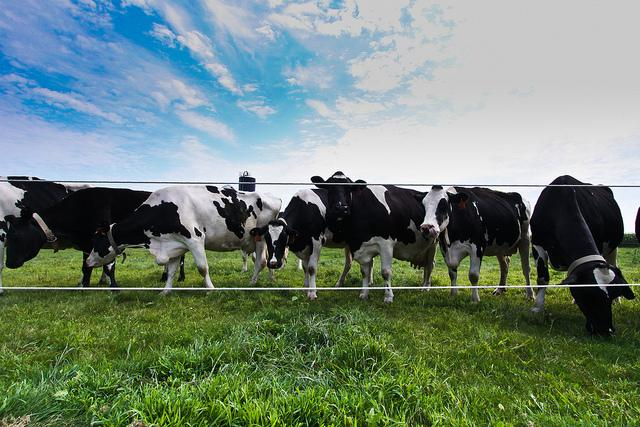What type of fence is shown here? Please explain your reasoning. electrified. It is an electrified fence so the animals can't run away 